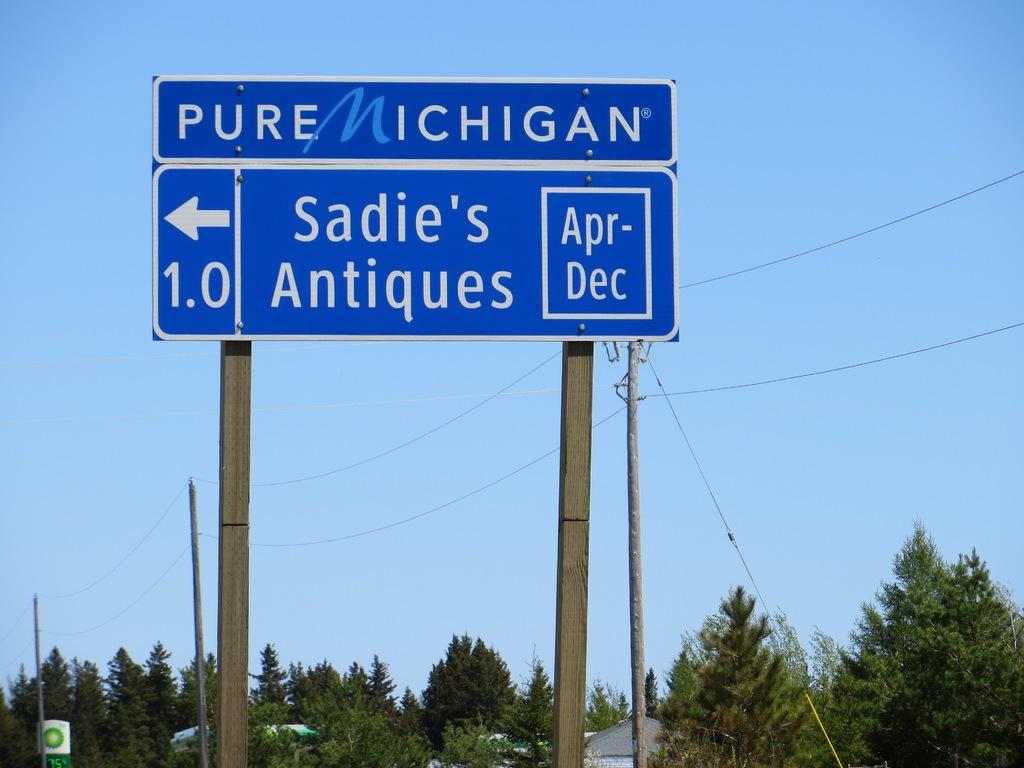<image>
Write a terse but informative summary of the picture. A sign saying PURE MICHIGAN Sadie's Antiques 1.0 Apr-Dec is shown. 